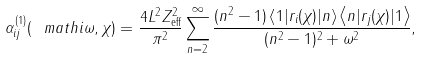Convert formula to latex. <formula><loc_0><loc_0><loc_500><loc_500>\alpha ^ { \left ( 1 \right ) } _ { i j } ( \ m a t h i \omega , \chi ) = \frac { 4 L ^ { 2 } Z ^ { 2 } _ { \text {eff} } } { \pi ^ { 2 } } \sum ^ { \infty } _ { n = 2 } \frac { ( n ^ { 2 } - 1 ) \left \langle 1 | r _ { i } ( \chi ) | n \right \rangle \left \langle n | r _ { j } ( \chi ) | 1 \right \rangle } { ( n ^ { 2 } - 1 ) ^ { 2 } + \omega ^ { 2 } } ,</formula> 